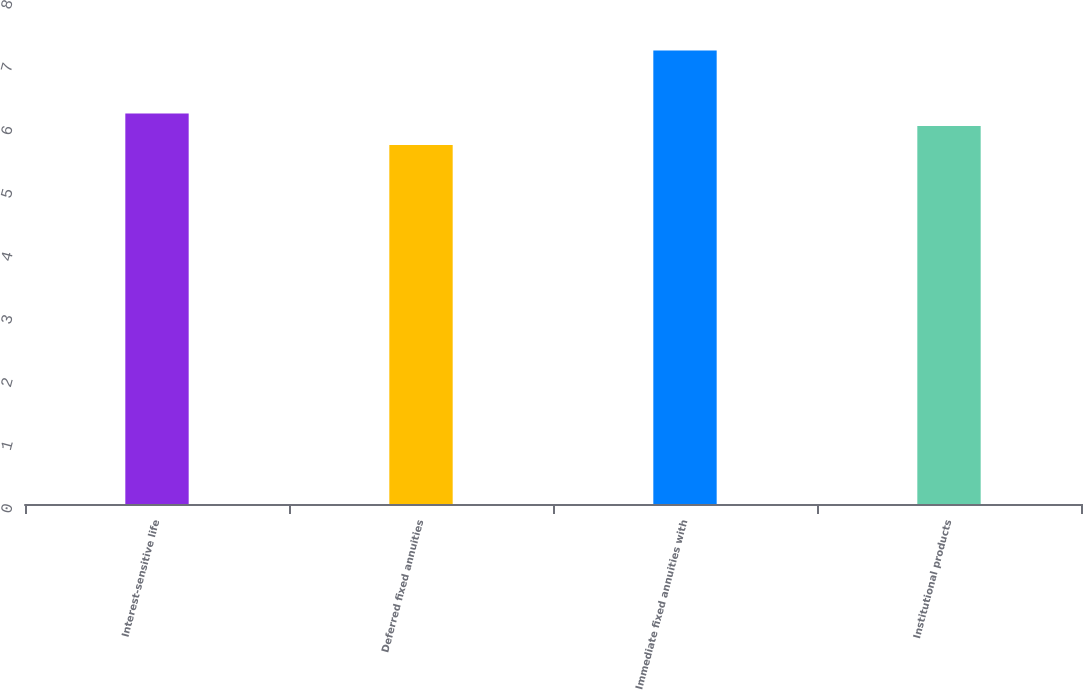Convert chart. <chart><loc_0><loc_0><loc_500><loc_500><bar_chart><fcel>Interest-sensitive life<fcel>Deferred fixed annuities<fcel>Immediate fixed annuities with<fcel>Institutional products<nl><fcel>6.2<fcel>5.7<fcel>7.2<fcel>6<nl></chart> 